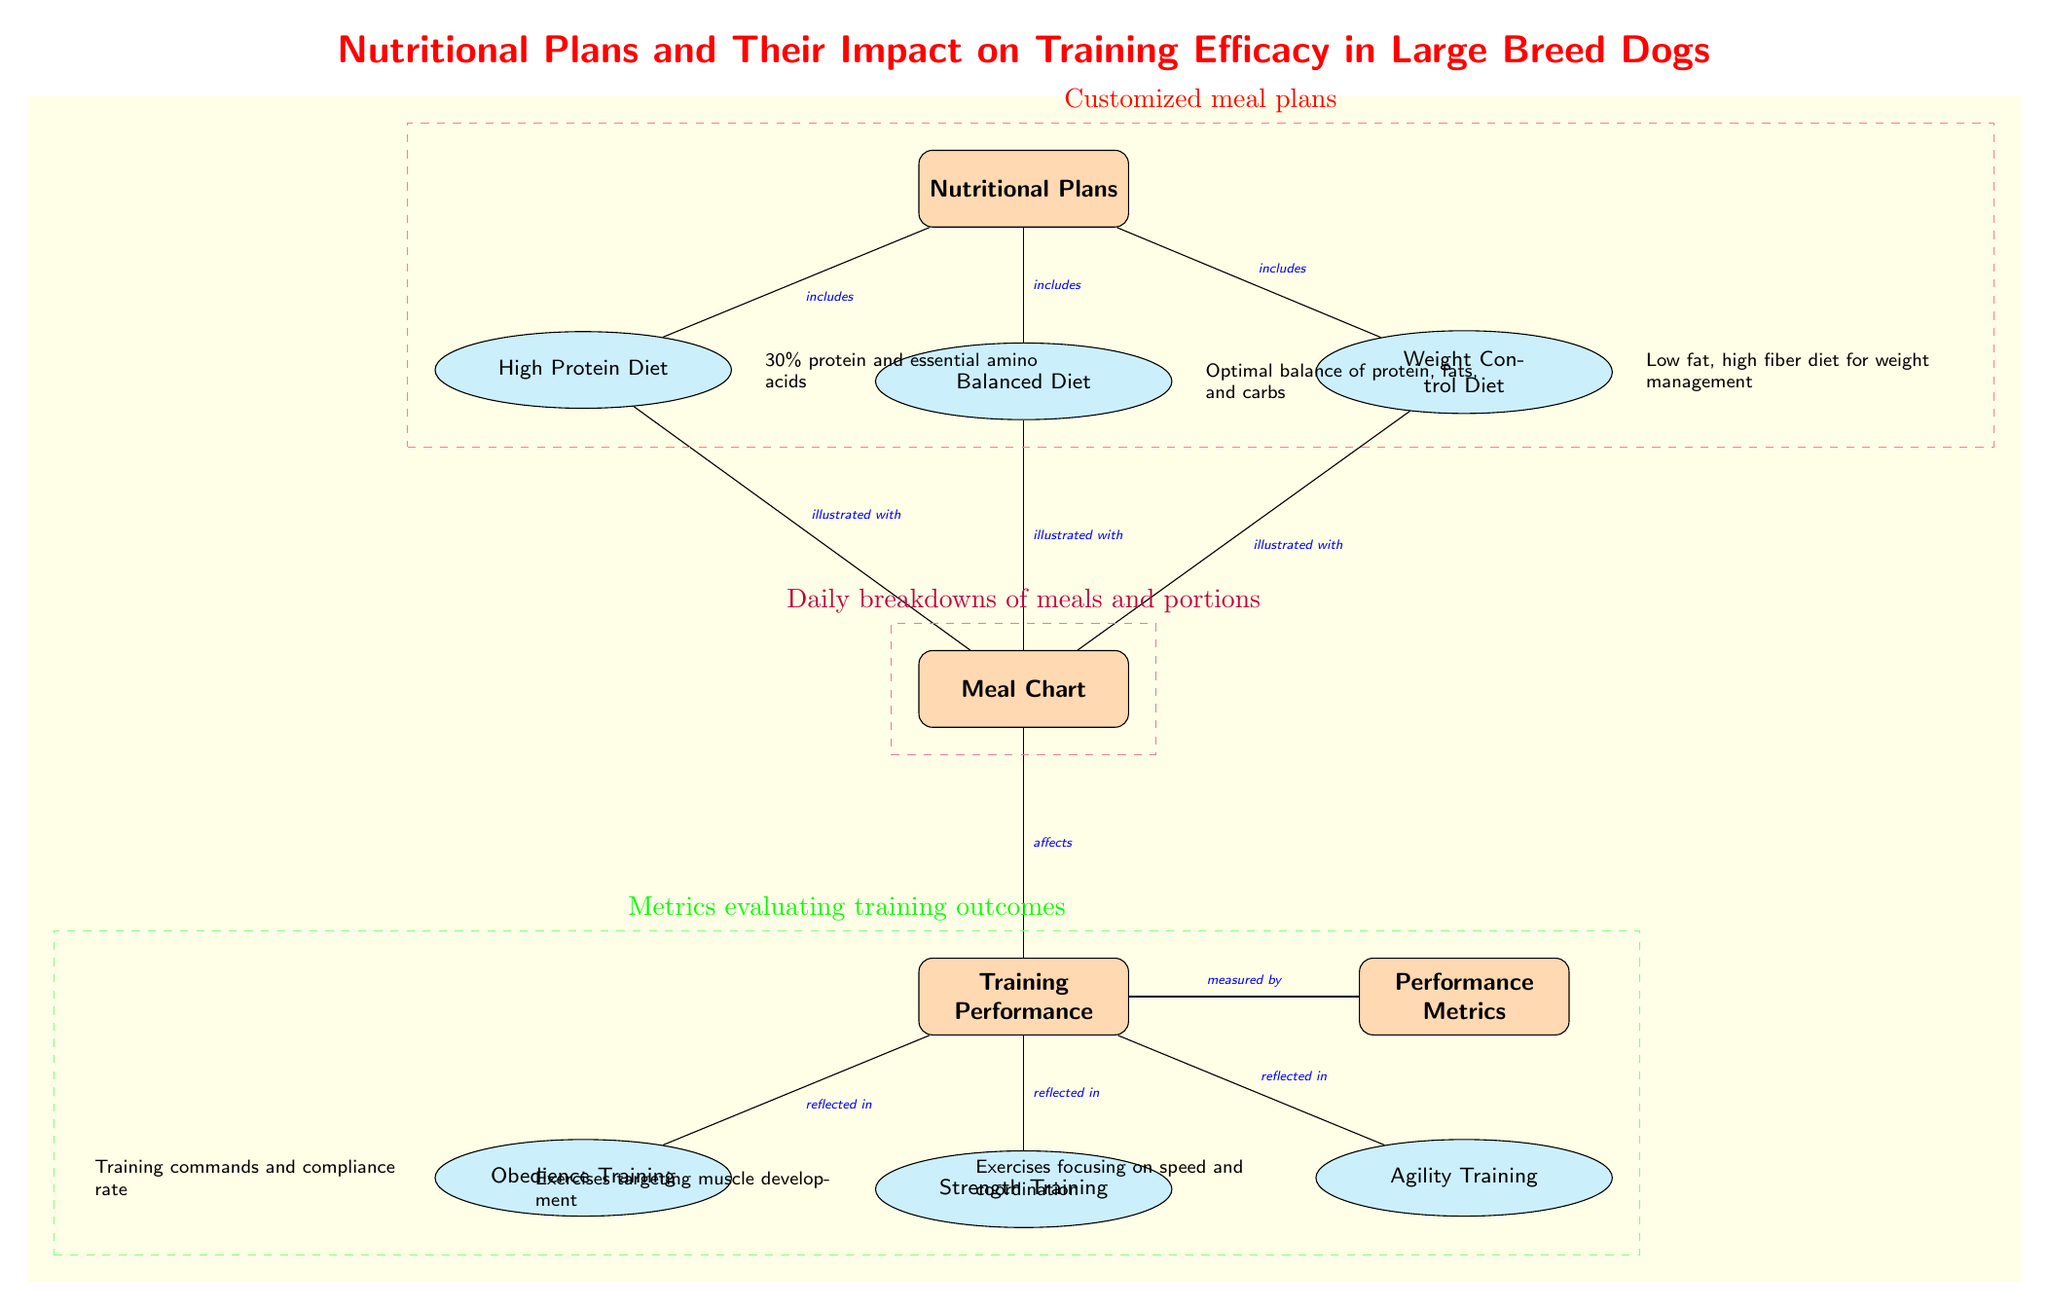What are the three types of nutritional plans? The diagram lists three types of nutritional plans connected to the main node labeled 'Nutritional Plans': High Protein Diet, Balanced Diet, and Weight Control Diet.
Answer: High Protein Diet, Balanced Diet, Weight Control Diet What is the main focus of the training performance node? The training performance node influences specific types of training such as Obedience Training, Strength Training, and Agility Training, indicating the different focus areas of training performance.
Answer: Obedience Training, Strength Training, Agility Training What type of diet is noted for having low fat and high fiber? The node labeled 'Weight Control Diet' is associated with the note that describes it as a low fat, high fiber diet for weight management.
Answer: Weight Control Diet How many types of training performance does the diagram show? The diagram demonstrates three distinct types of training performance as branches leading to the training performance node: Obedience Training, Strength Training, and Agility Training.
Answer: 3 Which diet includes 30% protein and essential amino acids? In the diagram, the 'High Protein Diet' node is directly associated with the note indicating that it includes 30% protein and essential amino acids.
Answer: High Protein Diet What does the arrow from 'Meal Chart' imply? The arrow from 'Meal Chart' points to 'Training Performance,' indicating that the meal chart directly affects the training performance of large breed dogs.
Answer: Affects What color represents the metrics evaluating training outcomes in the diagram? The metrics evaluating training outcomes are enclosed in a green dashed rectangle, distinguishing them from other elements in the diagram.
Answer: Green What type of dietary plan is emphasized for muscle development? The 'Strength Training' node relates to exercises targeting muscle development, implying that it emphasizes the importance of a proper diet for these exercises.
Answer: Strength Training 